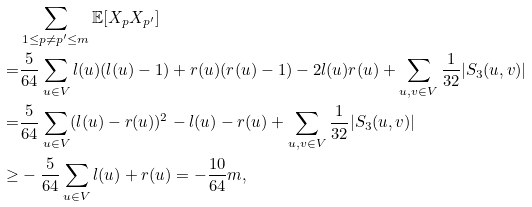Convert formula to latex. <formula><loc_0><loc_0><loc_500><loc_500>& \sum _ { 1 \leq p \neq p ^ { \prime } \leq m } \mathbb { E } [ X _ { p } X _ { p ^ { \prime } } ] \\ = & \frac { 5 } { 6 4 } \sum _ { u \in V } l ( u ) ( l ( u ) - 1 ) + r ( u ) ( r ( u ) - 1 ) - 2 l ( u ) r ( u ) + \sum _ { u , v \in V } \frac { 1 } { 3 2 } | S _ { 3 } ( u , v ) | \\ = & \frac { 5 } { 6 4 } \sum _ { u \in V } ( l ( u ) - r ( u ) ) ^ { 2 } - l ( u ) - r ( u ) + \sum _ { u , v \in V } \frac { 1 } { 3 2 } | S _ { 3 } ( u , v ) | \\ \geq & - \frac { 5 } { 6 4 } \sum _ { u \in V } l ( u ) + r ( u ) = - \frac { 1 0 } { 6 4 } m ,</formula> 